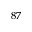<formula> <loc_0><loc_0><loc_500><loc_500>^ { 8 7 }</formula> 